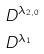<formula> <loc_0><loc_0><loc_500><loc_500>& D ^ { \lambda _ { 2 , 0 } } \\ & D ^ { \lambda _ { 1 } }</formula> 